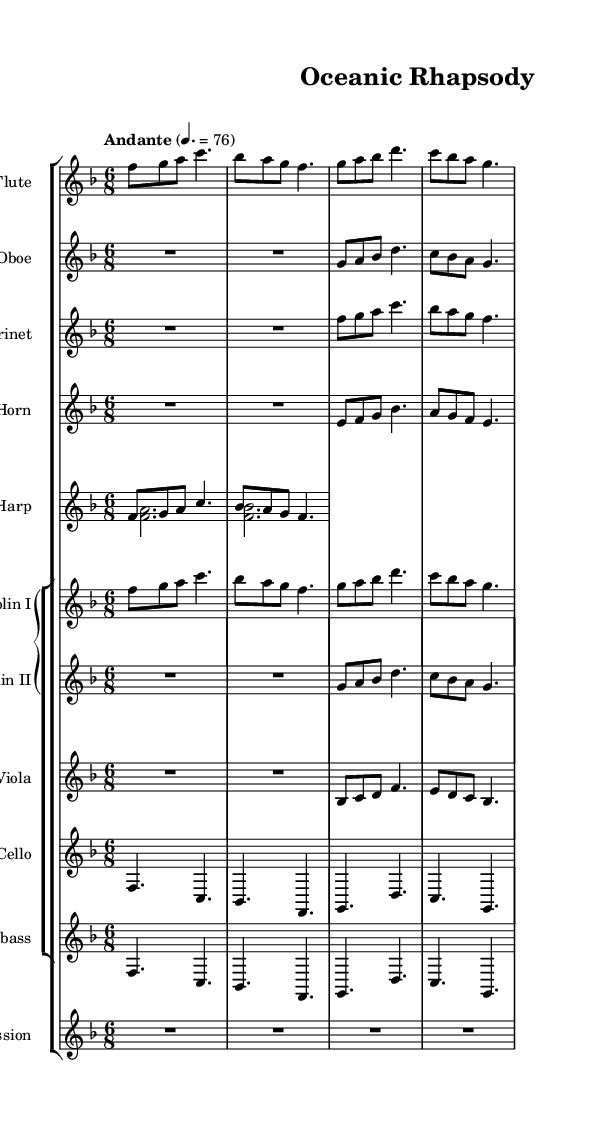What is the key signature of this music? The key signature is indicated at the beginning of the staff. In this case, there is one flat shown, which indicates that the music is in F major.
Answer: F major What is the time signature of this music? The time signature is found at the beginning of the first staff, which shows a 6 over 8 indicating that there are six eighth notes per measure.
Answer: 6/8 What is the tempo marking for this symphony? The tempo marking is usually found above the first measure of the music. Here it specifies "Andante," which means a moderately slow tempo.
Answer: Andante How many different instruments are featured in this score? By counting the different staves, we can see there are a total of eight distinct instruments contributing to the symphony's sound.
Answer: Eight Which instrument has the highest range in this score? The flute typically plays in a higher range than other woodwind and string instruments. The flute's notation shows the highest pitches compared to the other instruments.
Answer: Flute In which measure do the violins play together? By analyzing the sections for the violins, they play together in measures 1 through 3, where both Violin I and Violin II are noted simultaneously.
Answer: Measures 1 to 3 What type of musical texture does this symphony primarily exhibit? The symphony showcases a homophonic texture where melody lines are supported by harmonic accompaniment. The main melody can be traced in the flute and violins while harmonies are filled by the harp and other strings.
Answer: Homophonic 